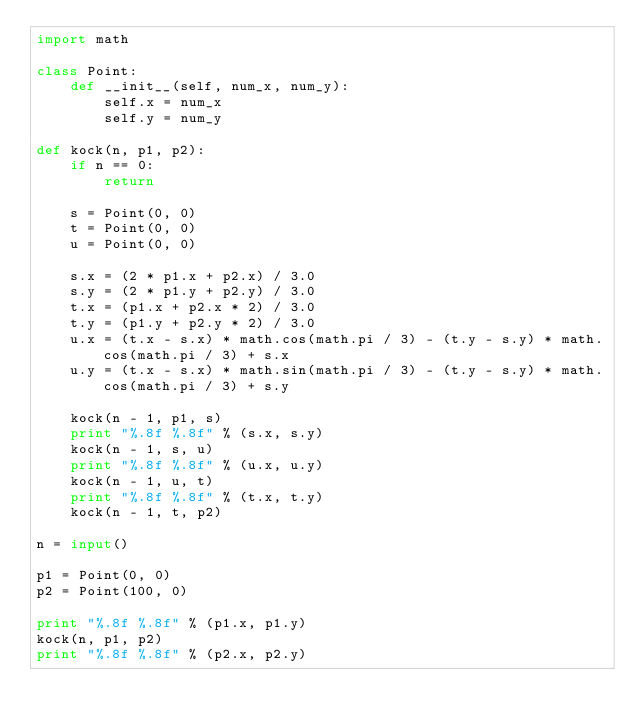<code> <loc_0><loc_0><loc_500><loc_500><_Python_>import math

class Point:
    def __init__(self, num_x, num_y):
        self.x = num_x
        self.y = num_y

def kock(n, p1, p2):
    if n == 0:
        return

    s = Point(0, 0)
    t = Point(0, 0)
    u = Point(0, 0)

    s.x = (2 * p1.x + p2.x) / 3.0
    s.y = (2 * p1.y + p2.y) / 3.0
    t.x = (p1.x + p2.x * 2) / 3.0
    t.y = (p1.y + p2.y * 2) / 3.0
    u.x = (t.x - s.x) * math.cos(math.pi / 3) - (t.y - s.y) * math.cos(math.pi / 3) + s.x
    u.y = (t.x - s.x) * math.sin(math.pi / 3) - (t.y - s.y) * math.cos(math.pi / 3) + s.y

    kock(n - 1, p1, s)
    print "%.8f %.8f" % (s.x, s.y)
    kock(n - 1, s, u)
    print "%.8f %.8f" % (u.x, u.y)
    kock(n - 1, u, t)
    print "%.8f %.8f" % (t.x, t.y)
    kock(n - 1, t, p2)

n = input()

p1 = Point(0, 0)
p2 = Point(100, 0)

print "%.8f %.8f" % (p1.x, p1.y)
kock(n, p1, p2)
print "%.8f %.8f" % (p2.x, p2.y)</code> 